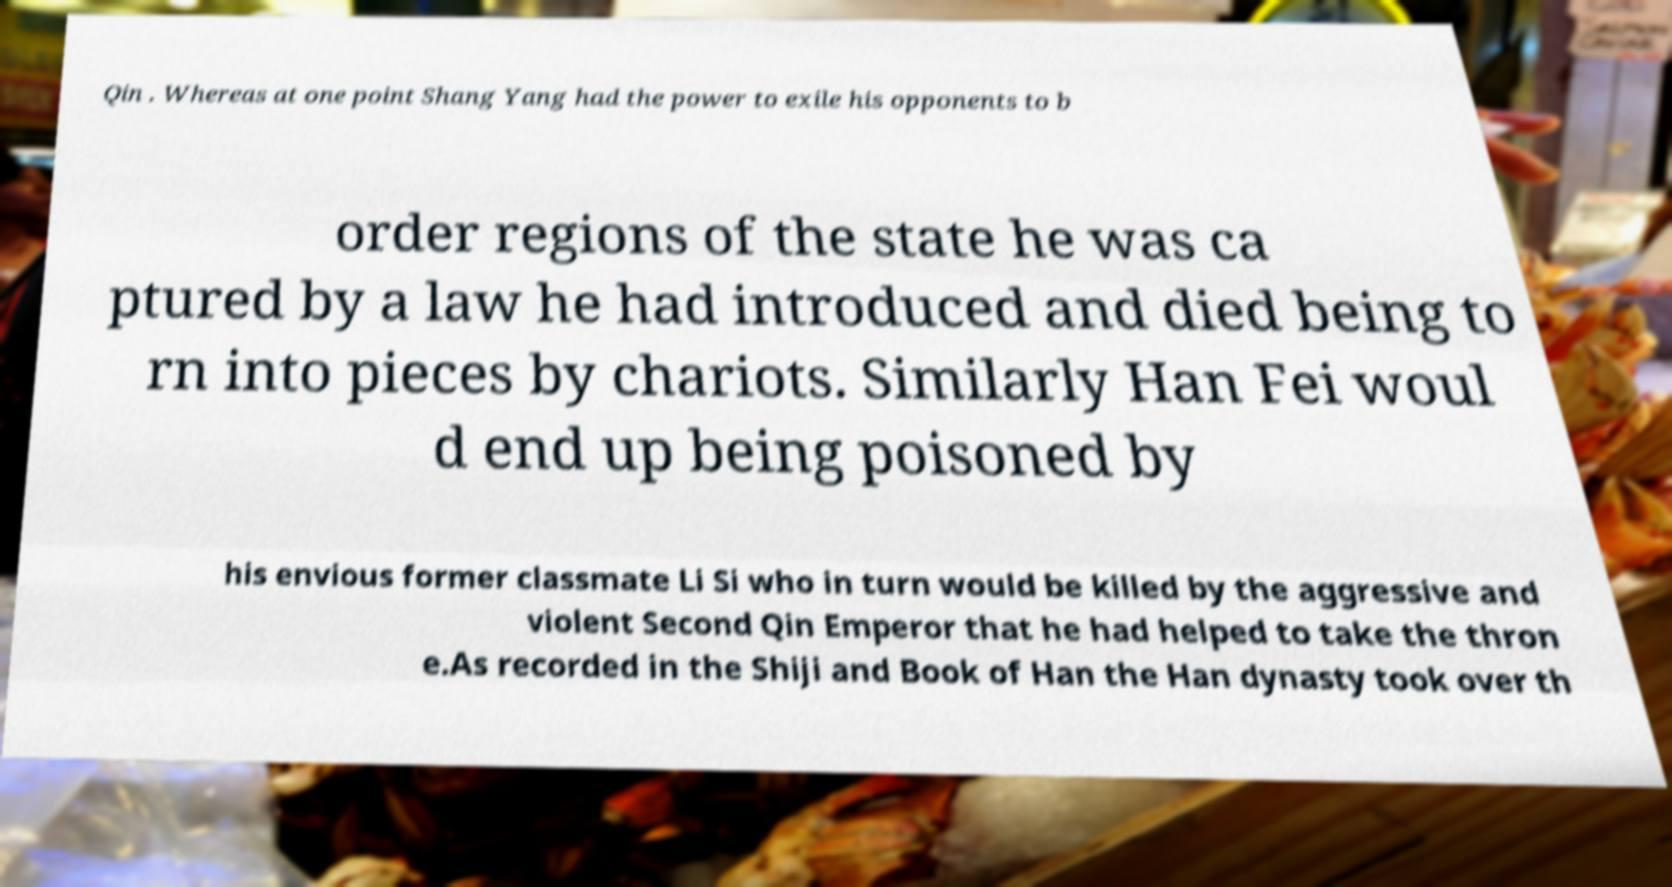Could you extract and type out the text from this image? Qin . Whereas at one point Shang Yang had the power to exile his opponents to b order regions of the state he was ca ptured by a law he had introduced and died being to rn into pieces by chariots. Similarly Han Fei woul d end up being poisoned by his envious former classmate Li Si who in turn would be killed by the aggressive and violent Second Qin Emperor that he had helped to take the thron e.As recorded in the Shiji and Book of Han the Han dynasty took over th 